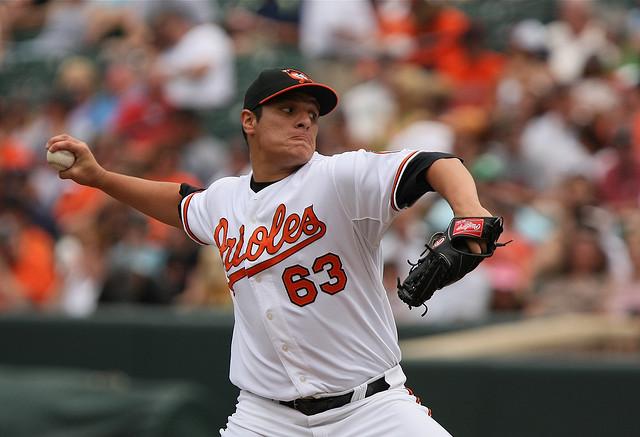What number is the jersey?
Answer briefly. 63. Did the man hit the ball?
Short answer required. No. What position does this guy play?
Answer briefly. Pitcher. What emotion is he feeling?
Write a very short answer. Determination. What team is he on?
Write a very short answer. Orioles. 